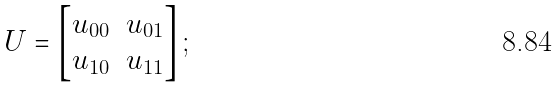Convert formula to latex. <formula><loc_0><loc_0><loc_500><loc_500>U = \left [ \begin{matrix} u _ { 0 0 } & u _ { 0 1 } \\ u _ { 1 0 } & u _ { 1 1 } \end{matrix} \right ] ;</formula> 